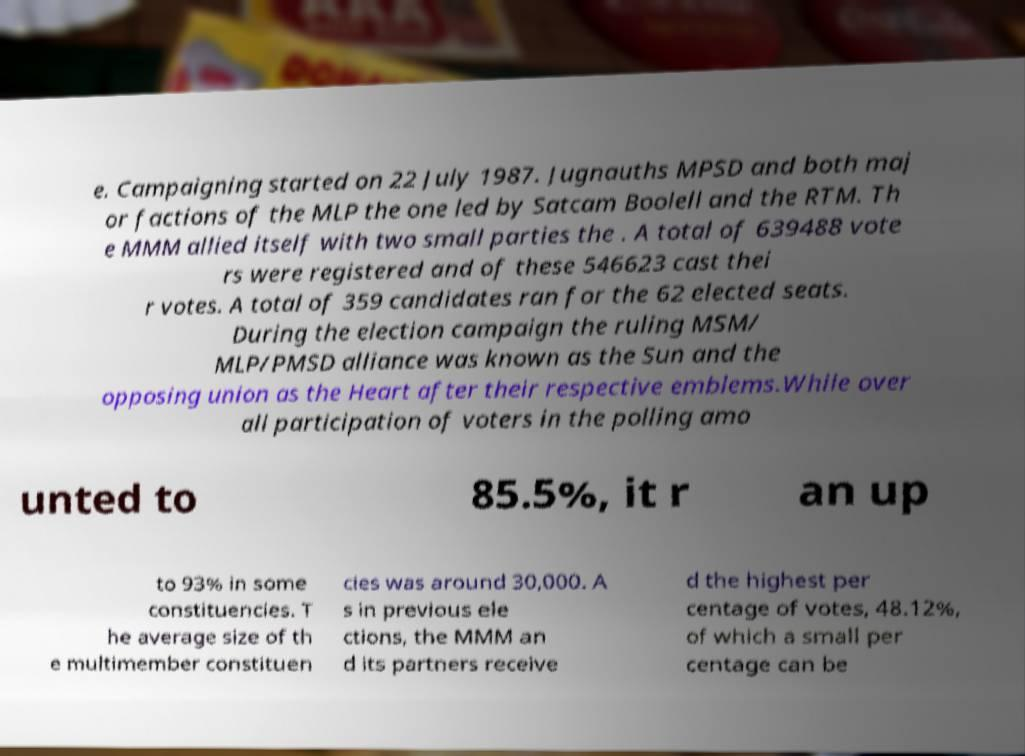Please identify and transcribe the text found in this image. e. Campaigning started on 22 July 1987. Jugnauths MPSD and both maj or factions of the MLP the one led by Satcam Boolell and the RTM. Th e MMM allied itself with two small parties the . A total of 639488 vote rs were registered and of these 546623 cast thei r votes. A total of 359 candidates ran for the 62 elected seats. During the election campaign the ruling MSM/ MLP/PMSD alliance was known as the Sun and the opposing union as the Heart after their respective emblems.While over all participation of voters in the polling amo unted to 85.5%, it r an up to 93% in some constituencies. T he average size of th e multimember constituen cies was around 30,000. A s in previous ele ctions, the MMM an d its partners receive d the highest per centage of votes, 48.12%, of which a small per centage can be 